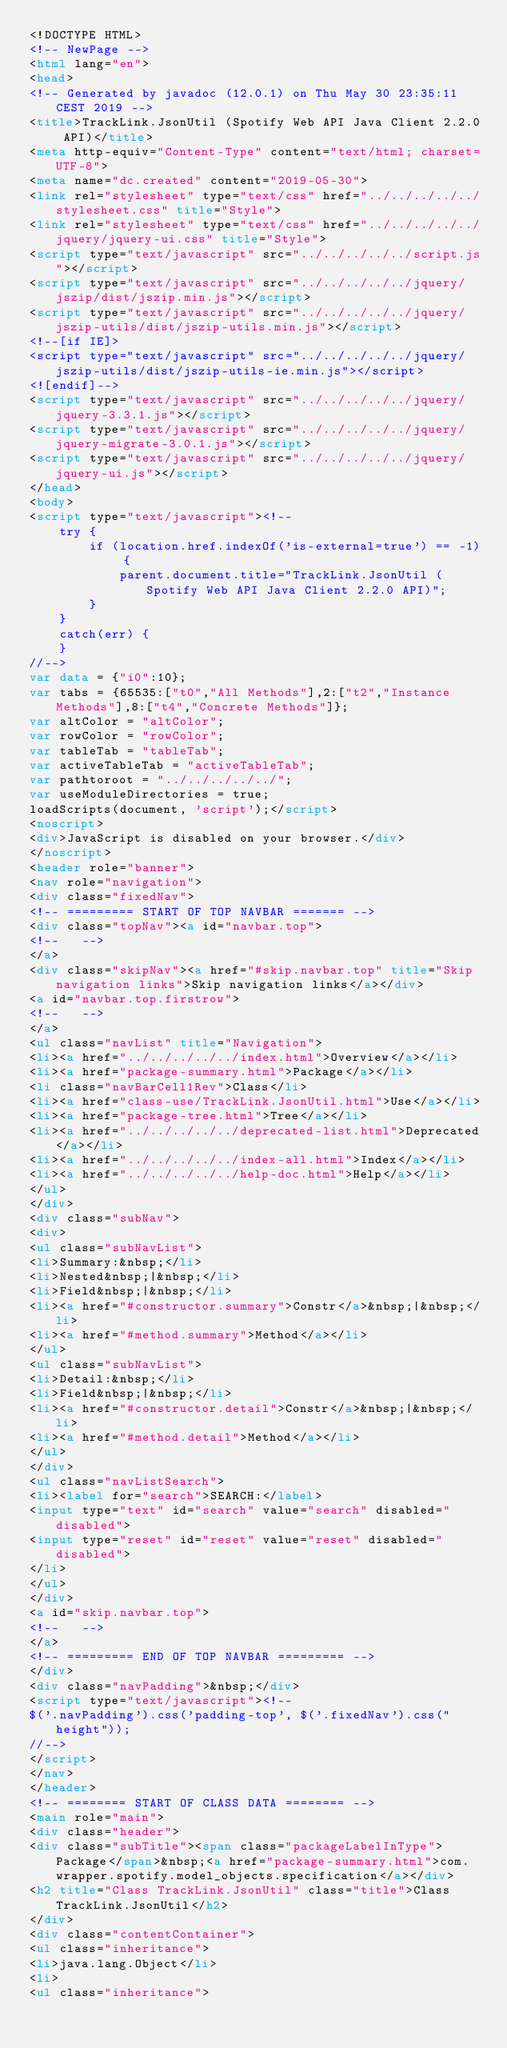Convert code to text. <code><loc_0><loc_0><loc_500><loc_500><_HTML_><!DOCTYPE HTML>
<!-- NewPage -->
<html lang="en">
<head>
<!-- Generated by javadoc (12.0.1) on Thu May 30 23:35:11 CEST 2019 -->
<title>TrackLink.JsonUtil (Spotify Web API Java Client 2.2.0 API)</title>
<meta http-equiv="Content-Type" content="text/html; charset=UTF-8">
<meta name="dc.created" content="2019-05-30">
<link rel="stylesheet" type="text/css" href="../../../../../stylesheet.css" title="Style">
<link rel="stylesheet" type="text/css" href="../../../../../jquery/jquery-ui.css" title="Style">
<script type="text/javascript" src="../../../../../script.js"></script>
<script type="text/javascript" src="../../../../../jquery/jszip/dist/jszip.min.js"></script>
<script type="text/javascript" src="../../../../../jquery/jszip-utils/dist/jszip-utils.min.js"></script>
<!--[if IE]>
<script type="text/javascript" src="../../../../../jquery/jszip-utils/dist/jszip-utils-ie.min.js"></script>
<![endif]-->
<script type="text/javascript" src="../../../../../jquery/jquery-3.3.1.js"></script>
<script type="text/javascript" src="../../../../../jquery/jquery-migrate-3.0.1.js"></script>
<script type="text/javascript" src="../../../../../jquery/jquery-ui.js"></script>
</head>
<body>
<script type="text/javascript"><!--
    try {
        if (location.href.indexOf('is-external=true') == -1) {
            parent.document.title="TrackLink.JsonUtil (Spotify Web API Java Client 2.2.0 API)";
        }
    }
    catch(err) {
    }
//-->
var data = {"i0":10};
var tabs = {65535:["t0","All Methods"],2:["t2","Instance Methods"],8:["t4","Concrete Methods"]};
var altColor = "altColor";
var rowColor = "rowColor";
var tableTab = "tableTab";
var activeTableTab = "activeTableTab";
var pathtoroot = "../../../../../";
var useModuleDirectories = true;
loadScripts(document, 'script');</script>
<noscript>
<div>JavaScript is disabled on your browser.</div>
</noscript>
<header role="banner">
<nav role="navigation">
<div class="fixedNav">
<!-- ========= START OF TOP NAVBAR ======= -->
<div class="topNav"><a id="navbar.top">
<!--   -->
</a>
<div class="skipNav"><a href="#skip.navbar.top" title="Skip navigation links">Skip navigation links</a></div>
<a id="navbar.top.firstrow">
<!--   -->
</a>
<ul class="navList" title="Navigation">
<li><a href="../../../../../index.html">Overview</a></li>
<li><a href="package-summary.html">Package</a></li>
<li class="navBarCell1Rev">Class</li>
<li><a href="class-use/TrackLink.JsonUtil.html">Use</a></li>
<li><a href="package-tree.html">Tree</a></li>
<li><a href="../../../../../deprecated-list.html">Deprecated</a></li>
<li><a href="../../../../../index-all.html">Index</a></li>
<li><a href="../../../../../help-doc.html">Help</a></li>
</ul>
</div>
<div class="subNav">
<div>
<ul class="subNavList">
<li>Summary:&nbsp;</li>
<li>Nested&nbsp;|&nbsp;</li>
<li>Field&nbsp;|&nbsp;</li>
<li><a href="#constructor.summary">Constr</a>&nbsp;|&nbsp;</li>
<li><a href="#method.summary">Method</a></li>
</ul>
<ul class="subNavList">
<li>Detail:&nbsp;</li>
<li>Field&nbsp;|&nbsp;</li>
<li><a href="#constructor.detail">Constr</a>&nbsp;|&nbsp;</li>
<li><a href="#method.detail">Method</a></li>
</ul>
</div>
<ul class="navListSearch">
<li><label for="search">SEARCH:</label>
<input type="text" id="search" value="search" disabled="disabled">
<input type="reset" id="reset" value="reset" disabled="disabled">
</li>
</ul>
</div>
<a id="skip.navbar.top">
<!--   -->
</a>
<!-- ========= END OF TOP NAVBAR ========= -->
</div>
<div class="navPadding">&nbsp;</div>
<script type="text/javascript"><!--
$('.navPadding').css('padding-top', $('.fixedNav').css("height"));
//-->
</script>
</nav>
</header>
<!-- ======== START OF CLASS DATA ======== -->
<main role="main">
<div class="header">
<div class="subTitle"><span class="packageLabelInType">Package</span>&nbsp;<a href="package-summary.html">com.wrapper.spotify.model_objects.specification</a></div>
<h2 title="Class TrackLink.JsonUtil" class="title">Class TrackLink.JsonUtil</h2>
</div>
<div class="contentContainer">
<ul class="inheritance">
<li>java.lang.Object</li>
<li>
<ul class="inheritance"></code> 